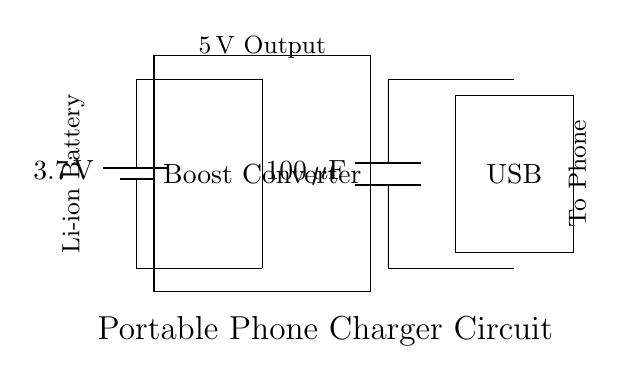What is the voltage of the battery? The battery is labeled with a voltage of 3.7 volts, indicating the potential difference it provides to the circuit.
Answer: 3.7 volts What type of converter is used in the circuit? The circuit contains a boost converter, which is designed to increase the voltage from the battery to the required output level.
Answer: Boost converter What is the capacitance value of the output capacitor? The circuit diagram shows an output capacitor labeled as 100 microfarads, which is a measure of its ability to store charge.
Answer: 100 microfarads What is the output voltage of the circuit? The output of the circuit is indicated to provide 5 volts, as shown by the label next to the output connection, indicating the voltage supplied to the device being charged.
Answer: 5 volts How is the battery connected to the boost converter? The battery is connected to the boost converter via two lines: one for the positive terminal and another for the negative terminal, allowing for a complete circuit flow.
Answer: Directly connected What is the purpose of the USB output in this circuit? The USB output is utilized to connect the charger to a phone or other device, providing a standardized interface for power delivery.
Answer: Power delivery interface What is the relationship between the output capacitor and the output voltage? The output capacitor works to stabilize the output voltage, reducing fluctuations and ensuring a steady voltage is supplied to the connected device.
Answer: Stabilizes output voltage 